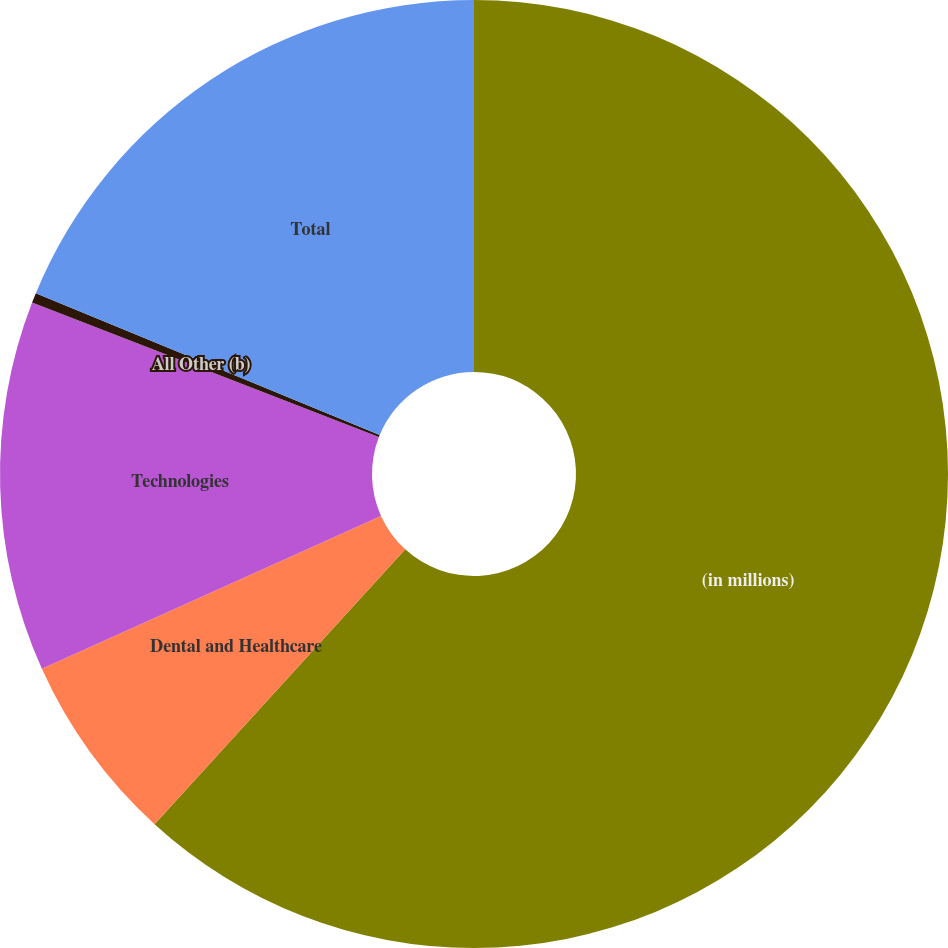<chart> <loc_0><loc_0><loc_500><loc_500><pie_chart><fcel>(in millions)<fcel>Dental and Healthcare<fcel>Technologies<fcel>All Other (b)<fcel>Total<nl><fcel>61.77%<fcel>6.49%<fcel>12.63%<fcel>0.34%<fcel>18.77%<nl></chart> 